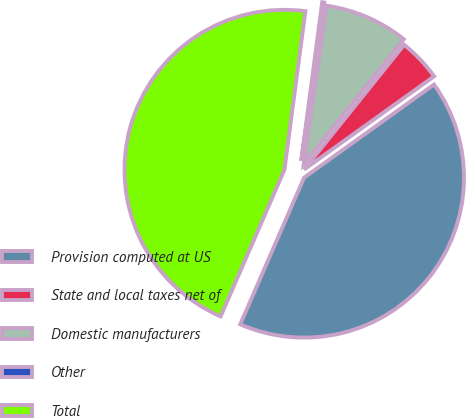Convert chart to OTSL. <chart><loc_0><loc_0><loc_500><loc_500><pie_chart><fcel>Provision computed at US<fcel>State and local taxes net of<fcel>Domestic manufacturers<fcel>Other<fcel>Total<nl><fcel>41.43%<fcel>4.34%<fcel>8.47%<fcel>0.2%<fcel>45.56%<nl></chart> 